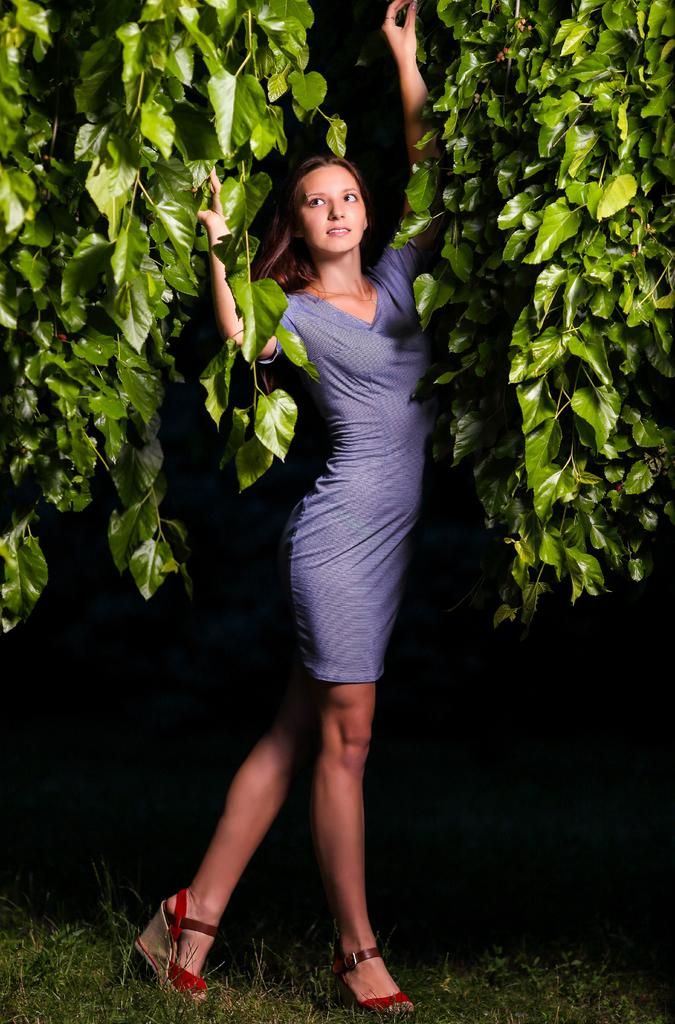Who is present in the image? There is a woman in the image. What is the woman's location in the image? The woman is standing on a grass field. What can be seen in the background of the image? There are plants visible in the background of the image. How many kittens are playing with the woman in the image? There are no kittens present in the image; it only features a woman standing on a grass field with plants visible in the background. 